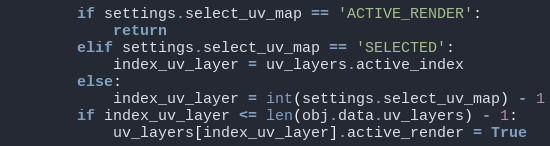Convert code to text. <code><loc_0><loc_0><loc_500><loc_500><_Python_>        if settings.select_uv_map == 'ACTIVE_RENDER':
            return
        elif settings.select_uv_map == 'SELECTED':
            index_uv_layer = uv_layers.active_index
        else:
            index_uv_layer = int(settings.select_uv_map) - 1
        if index_uv_layer <= len(obj.data.uv_layers) - 1:
            uv_layers[index_uv_layer].active_render = True
</code> 